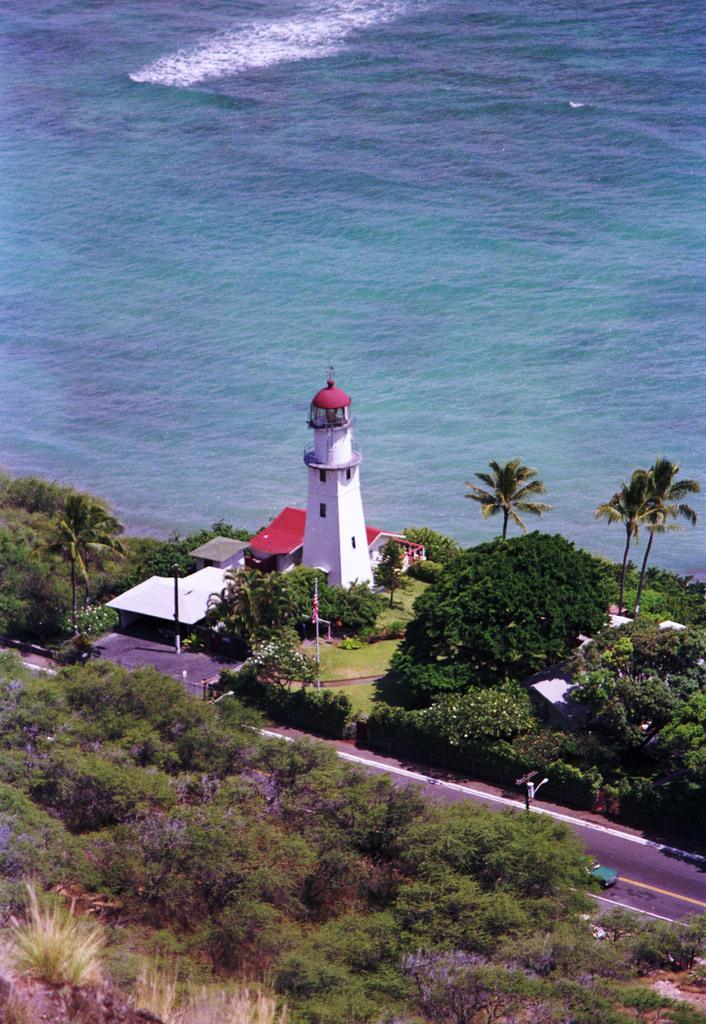Please provide a concise description of this image. In the image we can see there are lot of trees in the area and there is a light house. There are buildings and behind there is an ocean. 